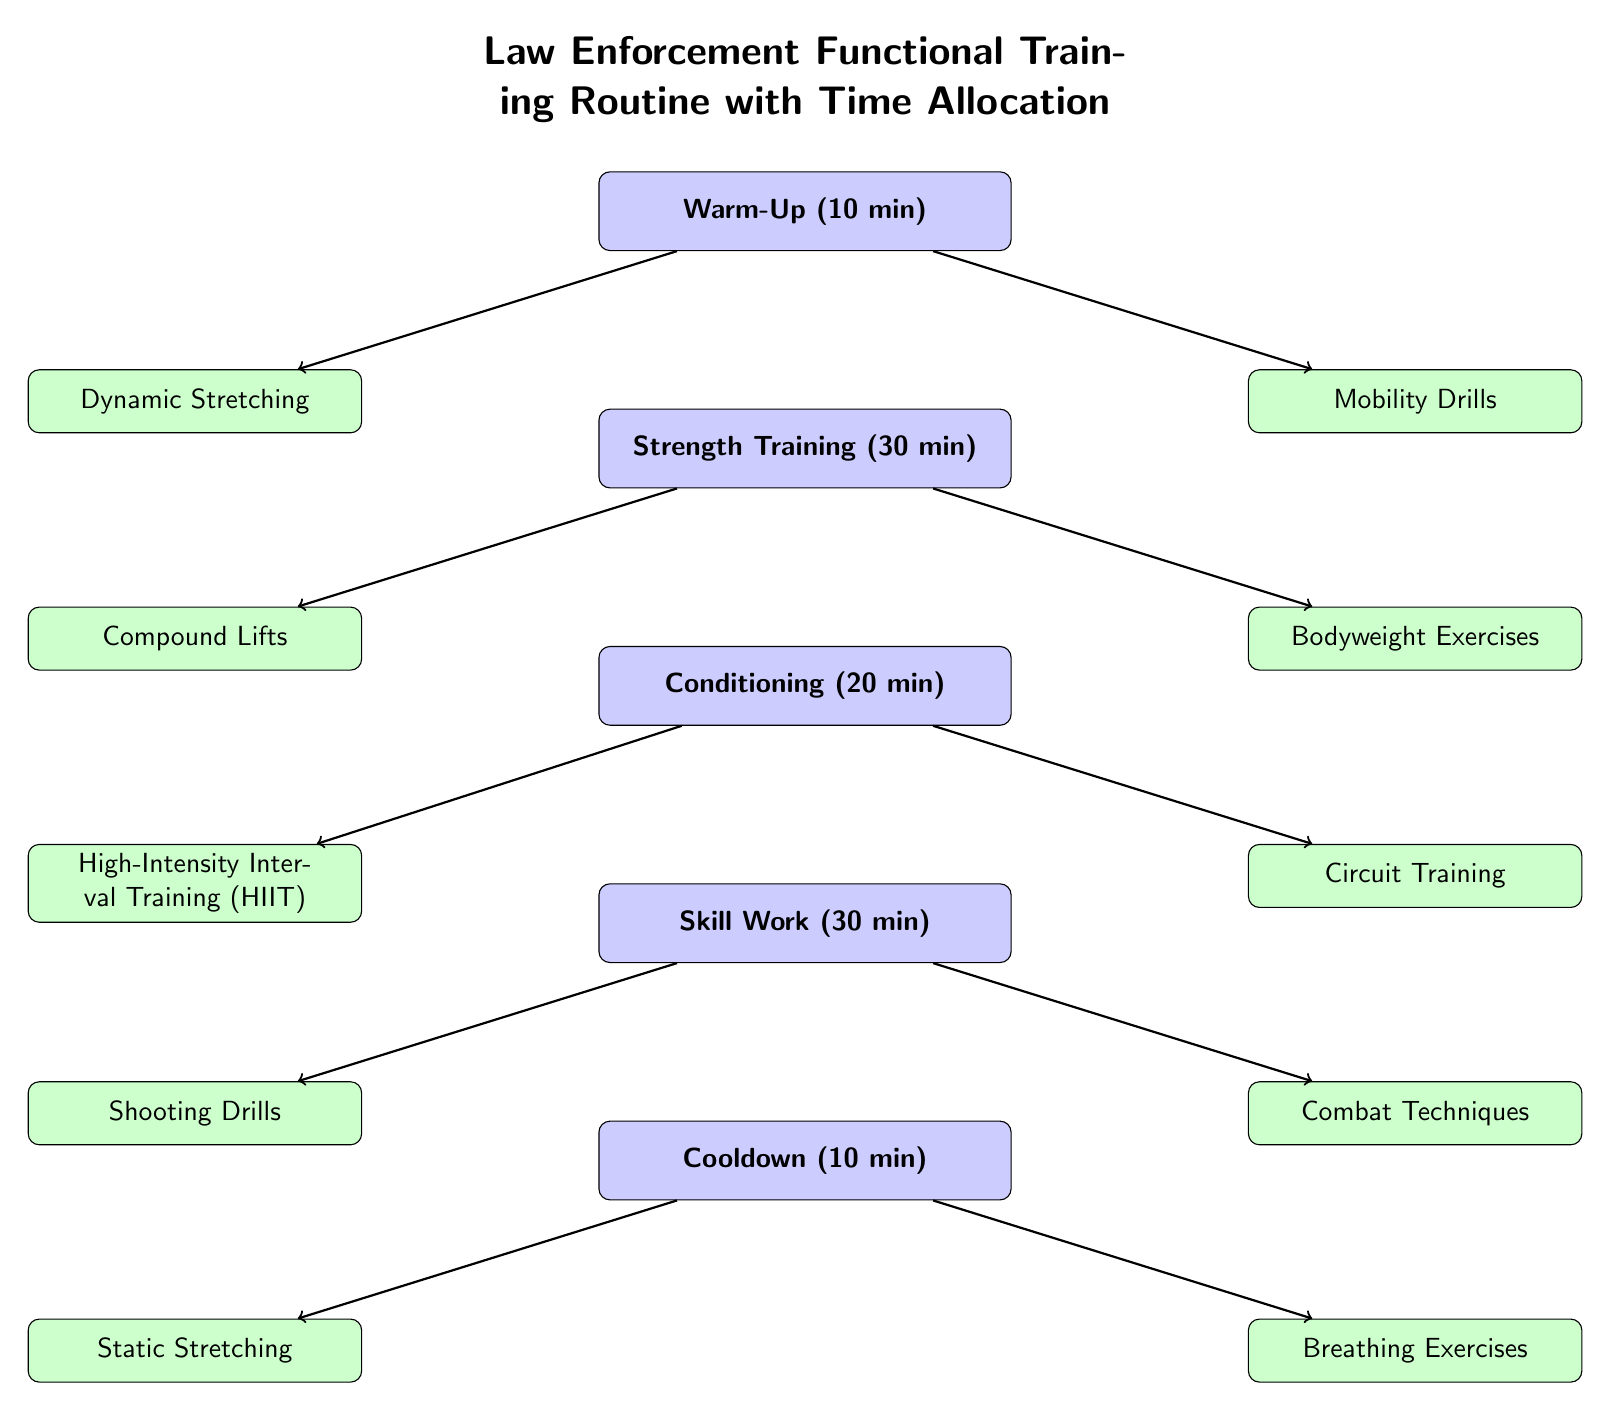What is the duration of the Warm-Up phase? The diagram states that the Warm-Up phase lasts for 10 minutes, as indicated in the main node labeled "Warm-Up."
Answer: 10 min How many main components are in the training routine? The diagram contains five main components: Warm-Up, Strength Training, Conditioning, Skill Work, and Cooldown. This is determined by counting the main nodes listed vertically.
Answer: 5 What type of training is included in the Conditioning phase? The Conditioning phase includes High-Intensity Interval Training (HIIT) and Circuit Training, as shown by the two sub-nodes branching from the Conditioning node.
Answer: HIIT and Circuit Training What is the total time allocated for Skill Work? The diagram allocates 30 minutes for Skill Work, as specified in the main node labeled "Skill Work."
Answer: 30 min Which phase follows Strength Training in the routine? The phase that follows Strength Training is Conditioning, as indicated by the vertical order in the diagram.
Answer: Conditioning How much time is allotted for Cooldown compared to Strength Training? The Cooldown phase is allotted 10 minutes, while Strength Training is allotted 30 minutes, making the Cooldown one-third the time of Strength Training.
Answer: 10 min vs 30 min What are the two types of exercises included in Strength Training? The two types of exercises featured in Strength Training are Compound Lifts and Bodyweight Exercises, as shown by the sub-nodes connected to the Strength Training node.
Answer: Compound Lifts and Bodyweight Exercises Which component has the shortest allocated time? Cooldown has the shortest allocated time at 10 minutes, emerging as the main component with the least duration in the training routine.
Answer: Cooldown How many sub-components are listed under the Warm-Up phase? The Warm-Up phase has two sub-components: Dynamic Stretching and Mobility Drills, which are displayed below the Warm-Up node.
Answer: 2 